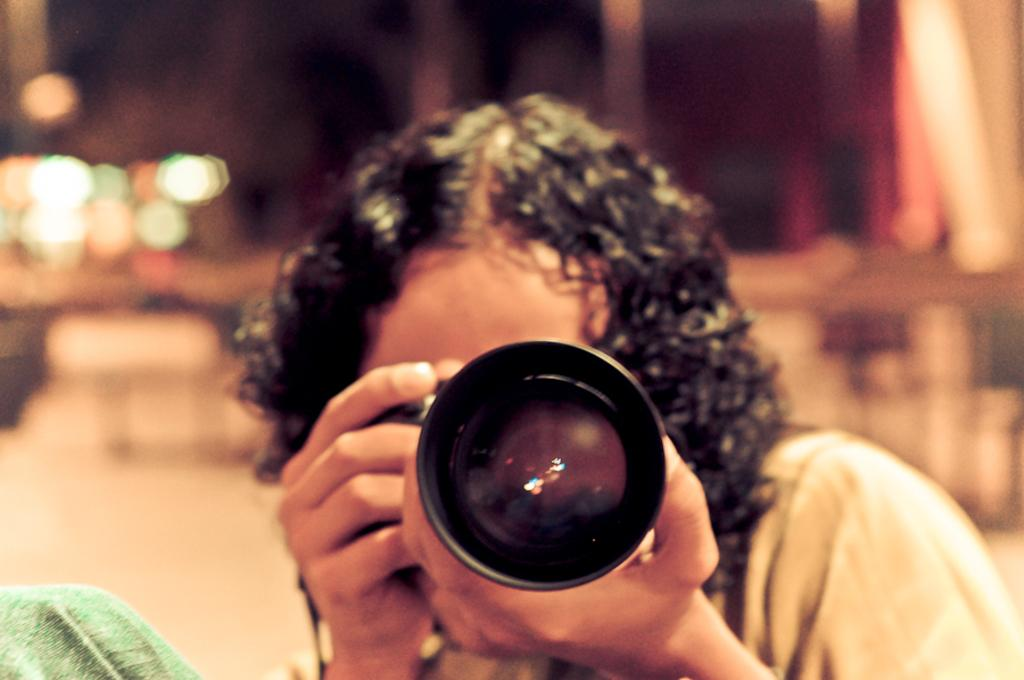What is the main subject of the image? There is a person in the image. What is the person holding in their hands? The person is holding a camera in their hands. What can be seen in the background of the image? There are lights visible in the background of the image. How would you describe the overall quality of the image? The image is blurry. What type of wrench is the person using to adjust the camera settings in the image? There is no wrench present in the image, and the person is not adjusting any camera settings. How many icicles are hanging from the person's camera in the image? There are no icicles present in the image, as it is not a cold environment. 